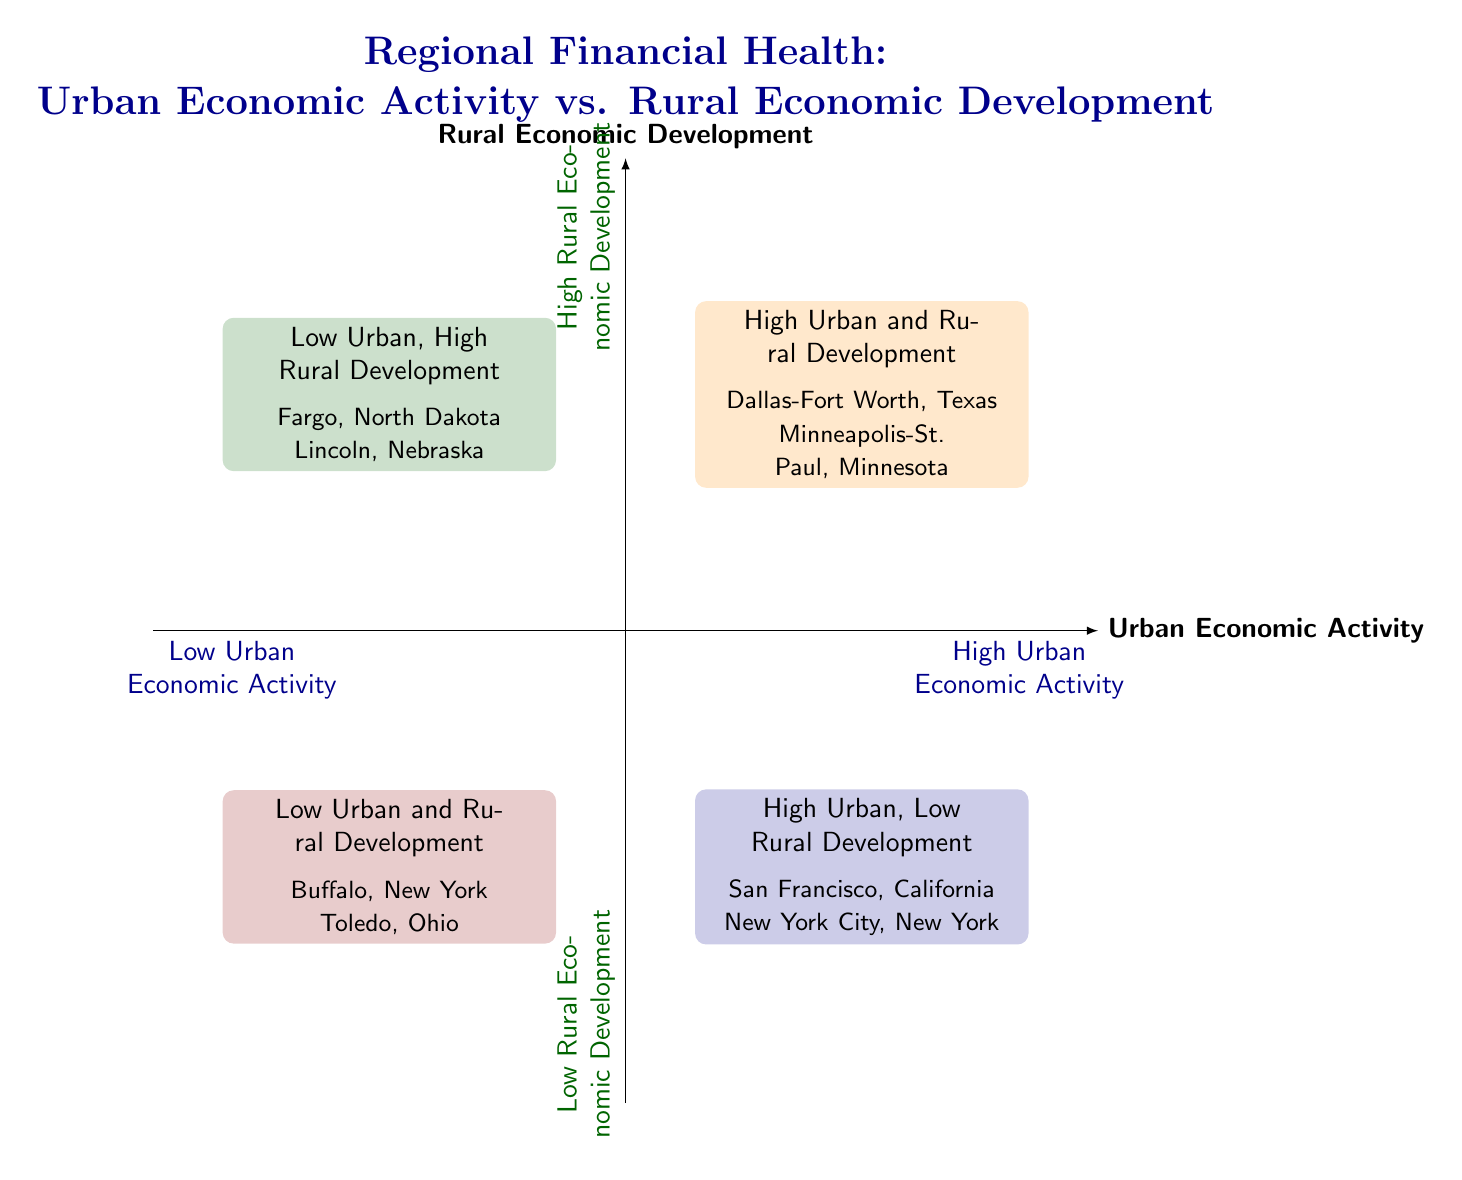What is the label of the top-right quadrant? The top-right quadrant is labeled "High Urban and Rural Development." This label is directly stated in the diagram, indicating regions with both robust urban economies and successful rural development.
Answer: High Urban and Rural Development Which cities are examples in the bottom-left quadrant? The bottom-left quadrant lists "Buffalo, New York" and "Toledo, Ohio" as examples. This information is sourced from the examples provided in that specific quadrant of the diagram.
Answer: Buffalo, New York; Toledo, Ohio How many quadrants are labeled in the diagram? The diagram features four labeled quadrants: top-right, top-left, bottom-right, and bottom-left. Each quadrant is dedicated to a combination of urban and rural economic activity.
Answer: Four What characterizes regions in the bottom-right quadrant? The bottom-right quadrant describes "High Urban, Low Rural Development," indicating urban centers with thriving economies yet struggling rural areas. This description encapsulates the economic conditions highlighted in that quadrant.
Answer: High Urban, Low Rural Development Which quadrant contains Fargo, North Dakota? Fargo, North Dakota is placed in the "Low Urban, High Rural Development" quadrant, specifically identified with the description and example mentioned in the top-left section.
Answer: Low Urban, High Rural Development What is the relationship between urban and rural economic activities in the top-left quadrant? The relationship in the top-left quadrant is one of low urban economic activity combined with high rural economic development, highlighting areas where rural economies flourish despite limited city activities.
Answer: Low urban, high rural development In which quadrant would you classify San Francisco, California? San Francisco, California is classified in the "High Urban, Low Rural Development" quadrant, characterized by a booming urban economy alongside challenges in surrounding rural regions as mentioned within that quadrant.
Answer: High Urban, Low Rural Development What is the significance of the color used in the bottom-left quadrant? The bottom-left quadrant is highlighted in dark red, which signifies "Low Urban and Rural Development." This color coding visually distinguishes the economically challenged regions in the diagram.
Answer: Dark red 